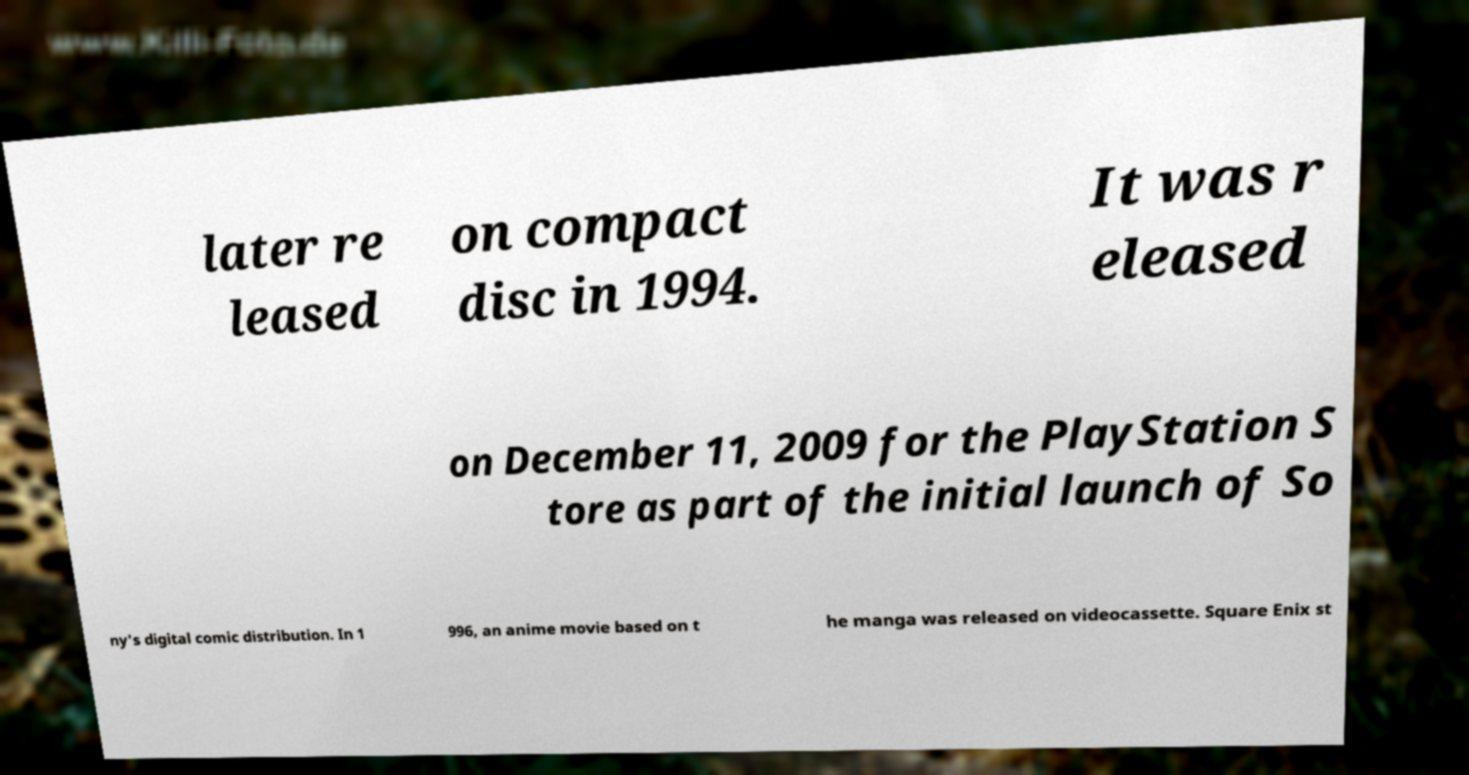Can you read and provide the text displayed in the image?This photo seems to have some interesting text. Can you extract and type it out for me? later re leased on compact disc in 1994. It was r eleased on December 11, 2009 for the PlayStation S tore as part of the initial launch of So ny's digital comic distribution. In 1 996, an anime movie based on t he manga was released on videocassette. Square Enix st 